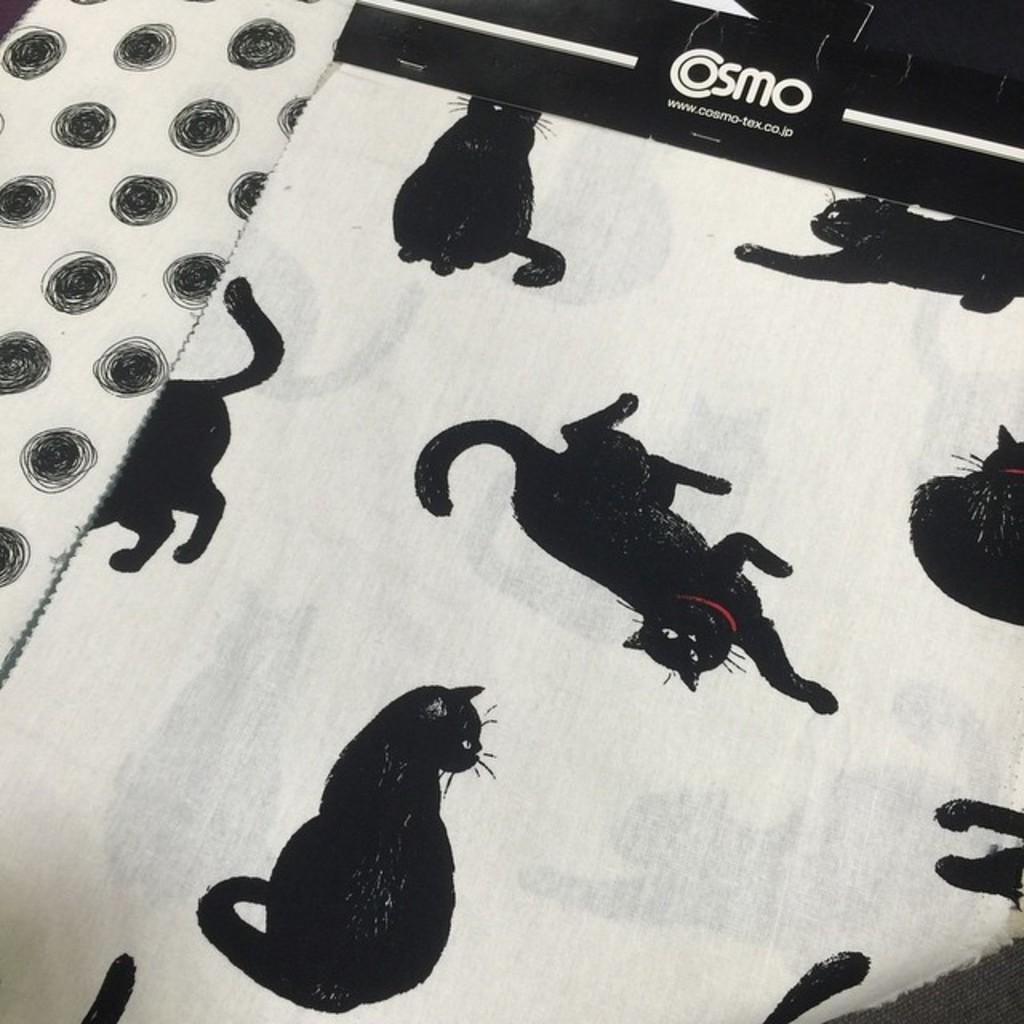How would you summarize this image in a sentence or two? In this picture I can see the cloth. I can see cats design on it 